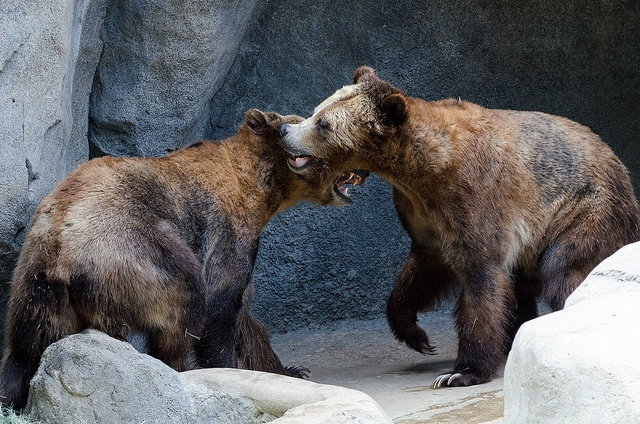Describe the objects in this image and their specific colors. I can see bear in gray, black, and darkgray tones and bear in gray, black, and darkgray tones in this image. 